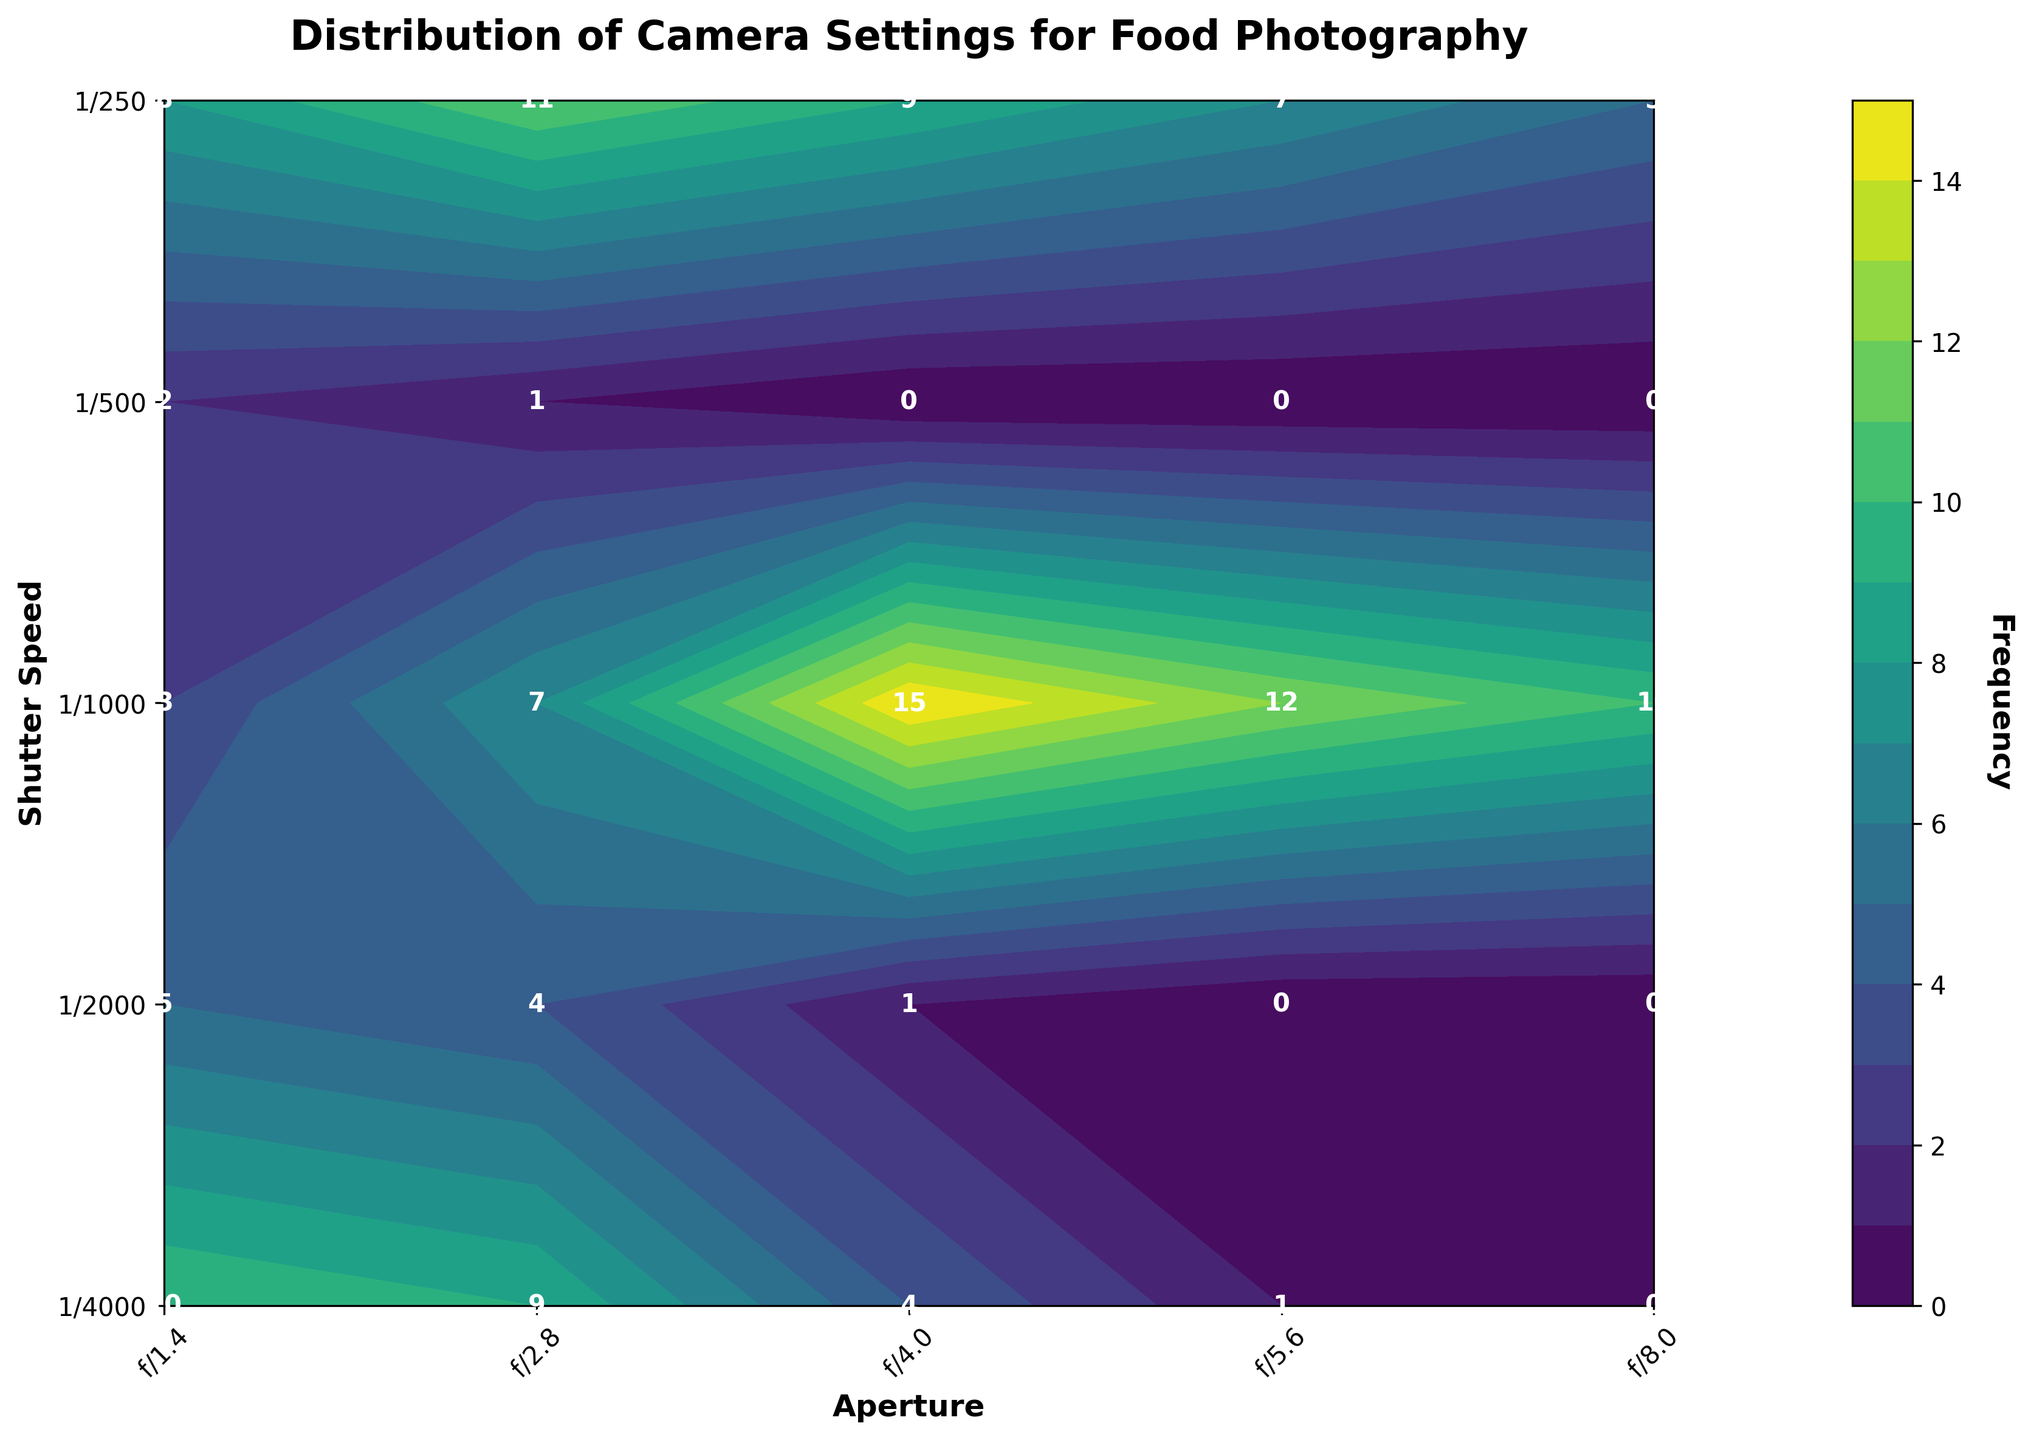What is the title of the figure? The title is usually located at the top of the figure. Look at the central top part of the plot.
Answer: Distribution of Camera Settings for Food Photography Describe the visual style used in the plot. The plot uses a specific style to make it visually appealing. Notice the background, gridlines, and overall feel.
Answer: Seaborn style ("seaborn-v0_8-deep") with a colorbar Which section of the plot shows the highest frequency? Look for the area in the contour plot where the color is the darkest or the label shows the highest number.
Answer: Shutter Speed 1/250, Aperture f/4.0, Frequency 15 How many frequency levels are there, and what color scheme is used? Check the gradient of different colors and the legend on the colorbar to count the distinct levels.
Answer: 15 levels, viridis color scheme What is the frequency at Shutter Speed 1/1000 and Aperture f/2.8? Locate the combination of Shutter Speed 1/1000 and Aperture f/2.8 on the axes, and read the number at that point.
Answer: 9 Which aperture setting has the most frequent usage for Shutter Speed 1/500? Find the row corresponding to Shutter Speed 1/500 and identify which column has the highest frequency number.
Answer: f/2.8 with a frequency of 11 Compare the frequency of Shutter Speed 1/250 and 1/1000 for Aperture f/1.4. Which one is higher? Look at the frequencies for Shutter Speed 1/250 and 1/1000 under Aperture f/1.4, and compare the two numbers.
Answer: 1/1000 is higher (10 vs. 3) What range of frequencies do you observe in the plot? Identify the minimum and maximum frequencies by inspecting all the values in the plot.
Answer: 0 to 15 For Shutter Speed 1/4000, which aperture setting is used most frequently? Find the row for Shutter Speed 1/4000 and see which aperture column has the highest frequency.
Answer: f/1.4 with a frequency of 2 Is there any Aperture setting that has no usage at all in the plot? Check all the labels in the different Aperture settings to see if any setting has all zero frequencies.
Answer: No aperture setting has zero usage overall 